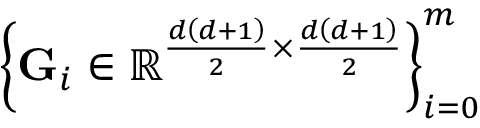<formula> <loc_0><loc_0><loc_500><loc_500>\left \{ { G } _ { i } \in \mathbb { R } ^ { \frac { d \left ( d + 1 \right ) } { 2 } \times \frac { d \left ( d + 1 \right ) } { 2 } } \right \} _ { i = 0 } ^ { m }</formula> 